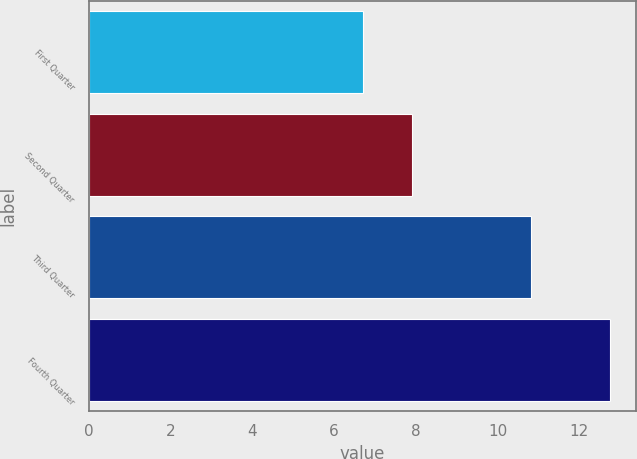Convert chart. <chart><loc_0><loc_0><loc_500><loc_500><bar_chart><fcel>First Quarter<fcel>Second Quarter<fcel>Third Quarter<fcel>Fourth Quarter<nl><fcel>6.72<fcel>7.9<fcel>10.82<fcel>12.76<nl></chart> 